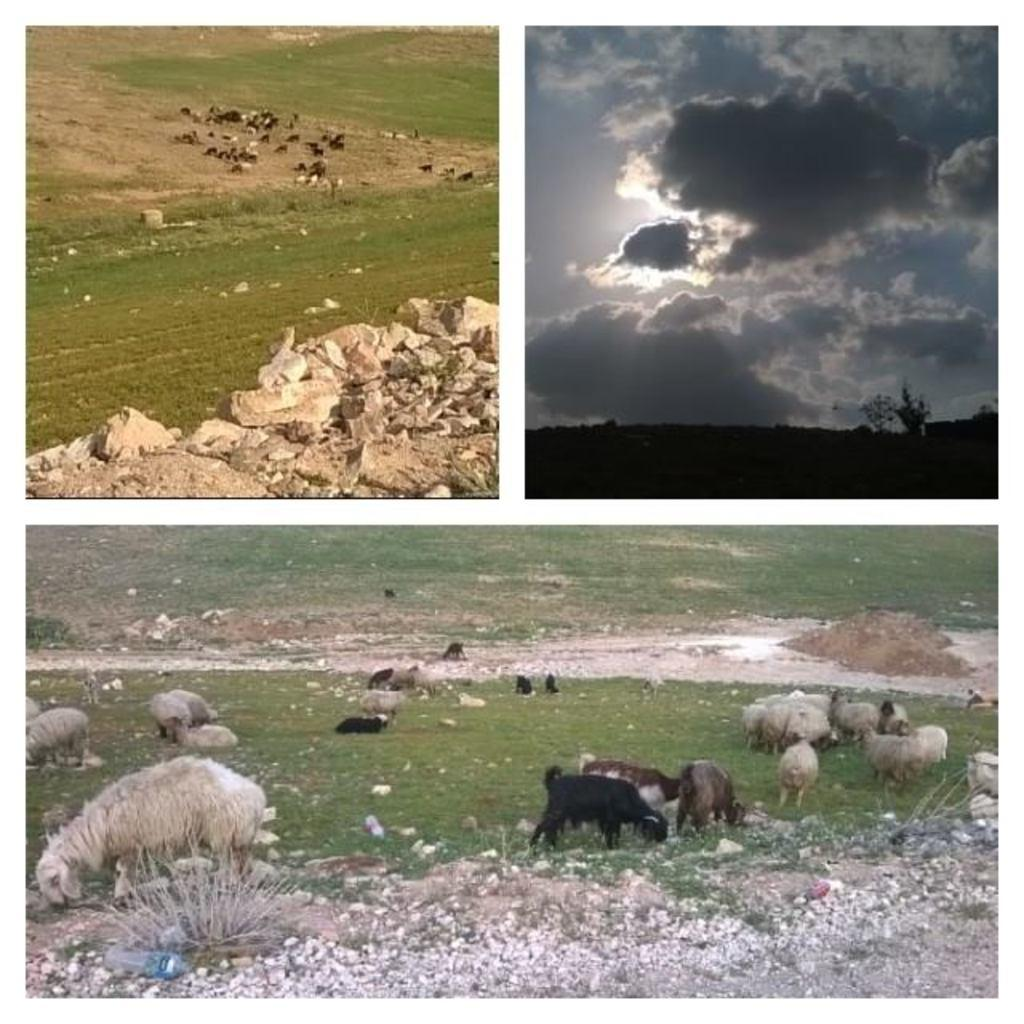What type of artwork is depicted in the image? The image is a collage. What can be seen on the ground in the image? There are animals on the ground. What type of vegetation is visible in the image? There is grass visible in the image. What object can be seen in the image? There is a bottle in the image. What type of natural elements are present in the image? There are stones in the image. What is visible in the background of the image? The sky is visible in the image, and clouds are present in the sky. What type of calculator is being used by the cattle in the image? There are no cattle or calculators present in the image. 